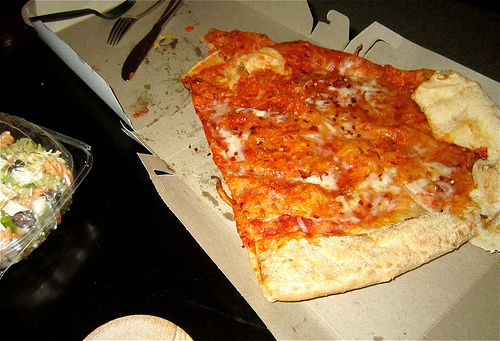How many forks are there? There is one fork visible in the image, lying to the left of the pizza, near the edge of the table. 